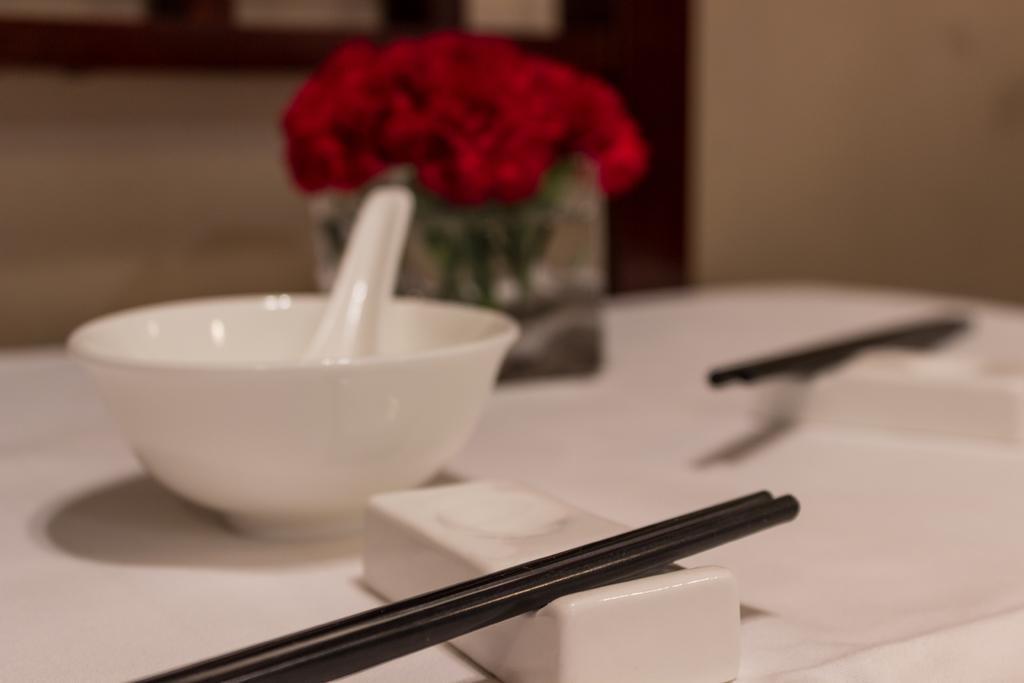Please provide a concise description of this image. This image is taken inside a room. In this image there is a table and on that table there were chop sticks, chop sticks holder, bowl, spoon and a flower vase with flowers in it. At the background there is a wall. 